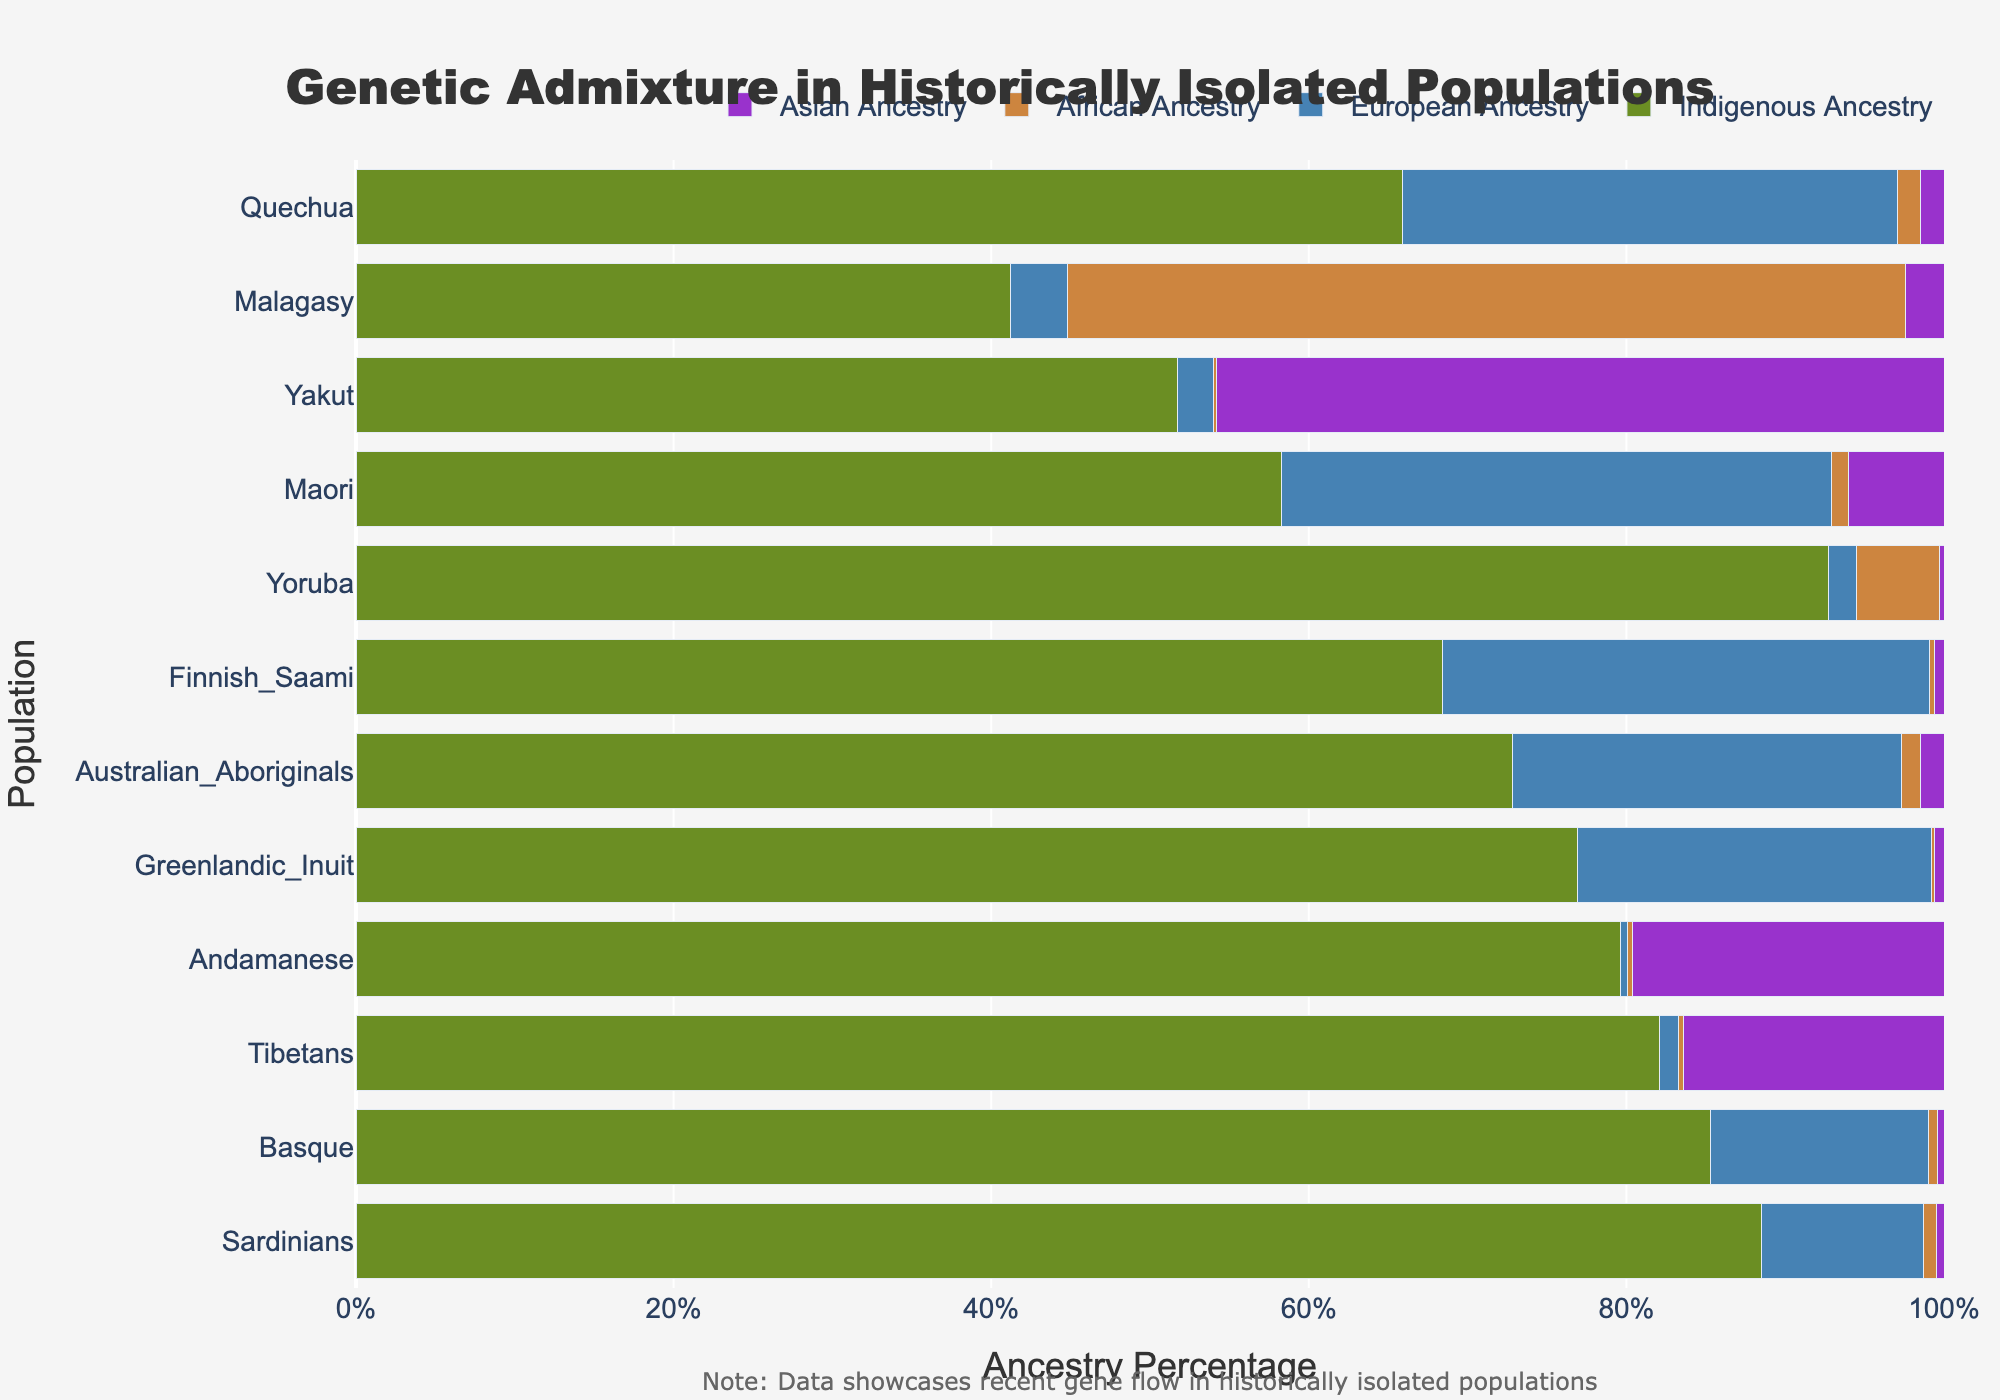Which population has the highest percentage of Indigenous Ancestry? The bar representing Indigenous Ancestry is the longest for the Yoruba population.
Answer: Yoruba Which population has the lowest percentage of Asian Ancestry? The bars representing Asian Ancestry are very small for multiple populations, but the Basque population has the smallest bar.
Answer: Basque What is the sum of European Ancestry percentages for the Sardinians and Basque populations? Sardinians have 10.2% and Basque have 13.7%, so the sum is 10.2 + 13.7.
Answer: 23.9 Among the listed populations, which one has the highest gene flow from African Ancestry? The bar representing African Ancestry is the longest for the Malagasy population.
Answer: Malagasy Compare the percentage of Indigenous Ancestry between the Greenlandic Inuit and the Tibetan populations. Which has a higher percentage? Greenlandic Inuit have 76.9% Indigenous Ancestry, whereas Tibetans have 82.1%. Therefore, Tibetans have a higher percentage.
Answer: Tibetans What is the average percentage of Indigenous Ancestry across the Sardinians, Basque, and Andamanese populations? Sum the percentages: 88.5 (Sardinians) + 85.3 (Basque) + 79.6 (Andamanese) = 253.4. Divide by 3 to get the average: 253.4 / 3.
Answer: 84.5 What is the difference in European Ancestry percentages between the Finnish Saami and the Quechua populations? Finnish Saami have 30.7% European Ancestry and Quechua have 31.2%, so the difference is 31.2 - 30.7.
Answer: 0.5 Which population has a higher percentage of African Ancestry: the Andamanese or the Yoruba? Comparing the bars for African Ancestry, Yoruba have 5.2% and Andamanese have 0.3%, so Yoruba have a higher percentage.
Answer: Yoruba Which ancestry category has the highest percentage in the Australian Aboriginals population? The bar representing European Ancestry is the longest for the Australian Aboriginals.
Answer: European Ancestry What is the combined percentage of African and Asian Ancestry in the Malagasy population? Malagasy have 52.8% African Ancestry and 2.4% Asian Ancestry, so the combined percentage is 52.8 + 2.4.
Answer: 55.2 